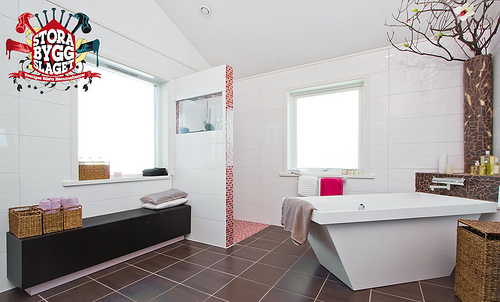Identify the text displayed in this image. STORA BYGG SLAGET 